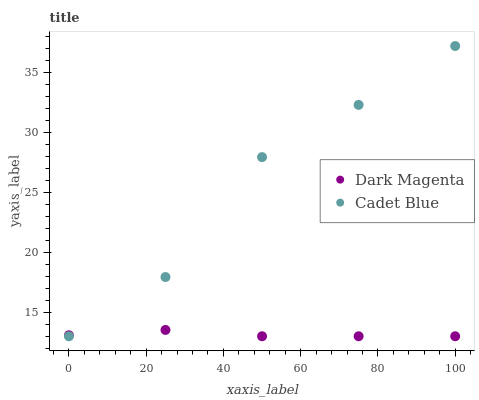Does Dark Magenta have the minimum area under the curve?
Answer yes or no. Yes. Does Cadet Blue have the maximum area under the curve?
Answer yes or no. Yes. Does Dark Magenta have the maximum area under the curve?
Answer yes or no. No. Is Dark Magenta the smoothest?
Answer yes or no. Yes. Is Cadet Blue the roughest?
Answer yes or no. Yes. Is Dark Magenta the roughest?
Answer yes or no. No. Does Cadet Blue have the lowest value?
Answer yes or no. Yes. Does Cadet Blue have the highest value?
Answer yes or no. Yes. Does Dark Magenta have the highest value?
Answer yes or no. No. Does Dark Magenta intersect Cadet Blue?
Answer yes or no. Yes. Is Dark Magenta less than Cadet Blue?
Answer yes or no. No. Is Dark Magenta greater than Cadet Blue?
Answer yes or no. No. 